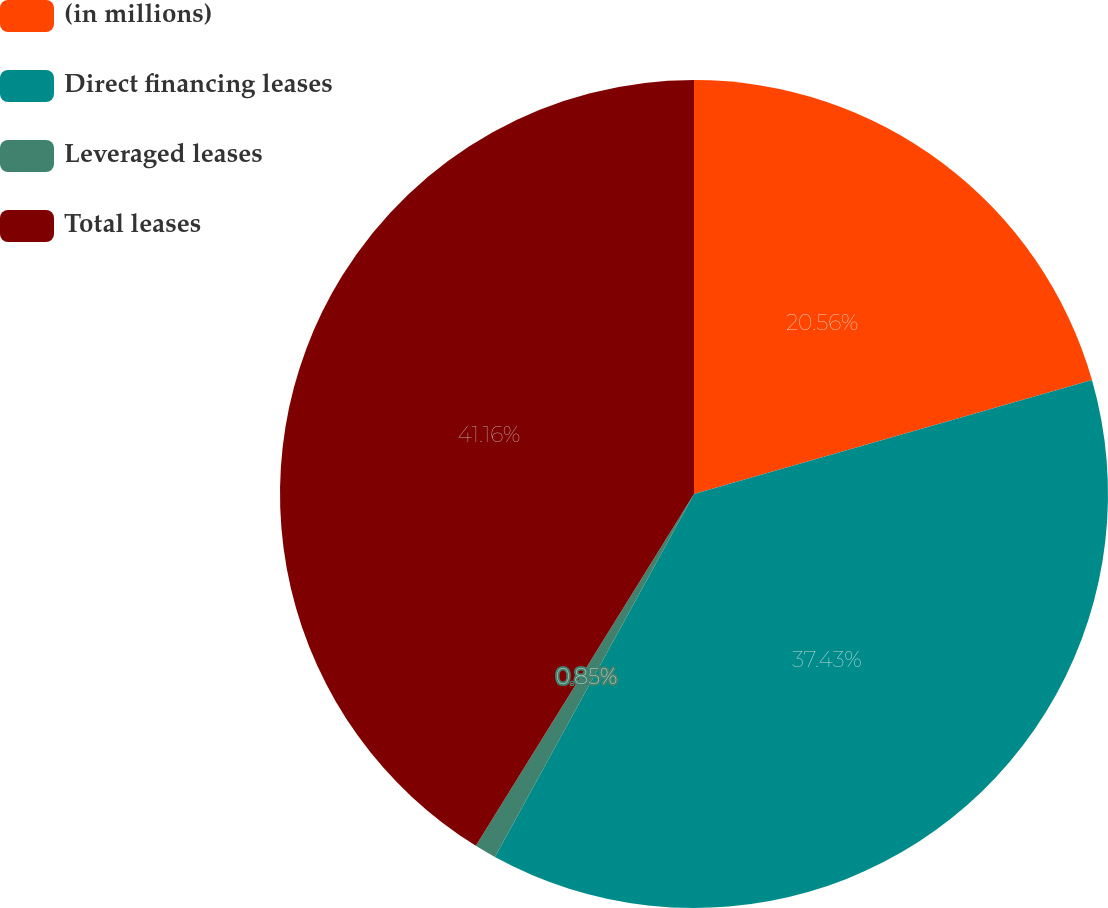Convert chart. <chart><loc_0><loc_0><loc_500><loc_500><pie_chart><fcel>(in millions)<fcel>Direct financing leases<fcel>Leveraged leases<fcel>Total leases<nl><fcel>20.56%<fcel>37.43%<fcel>0.85%<fcel>41.17%<nl></chart> 